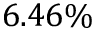Convert formula to latex. <formula><loc_0><loc_0><loc_500><loc_500>6 . 4 6 \%</formula> 